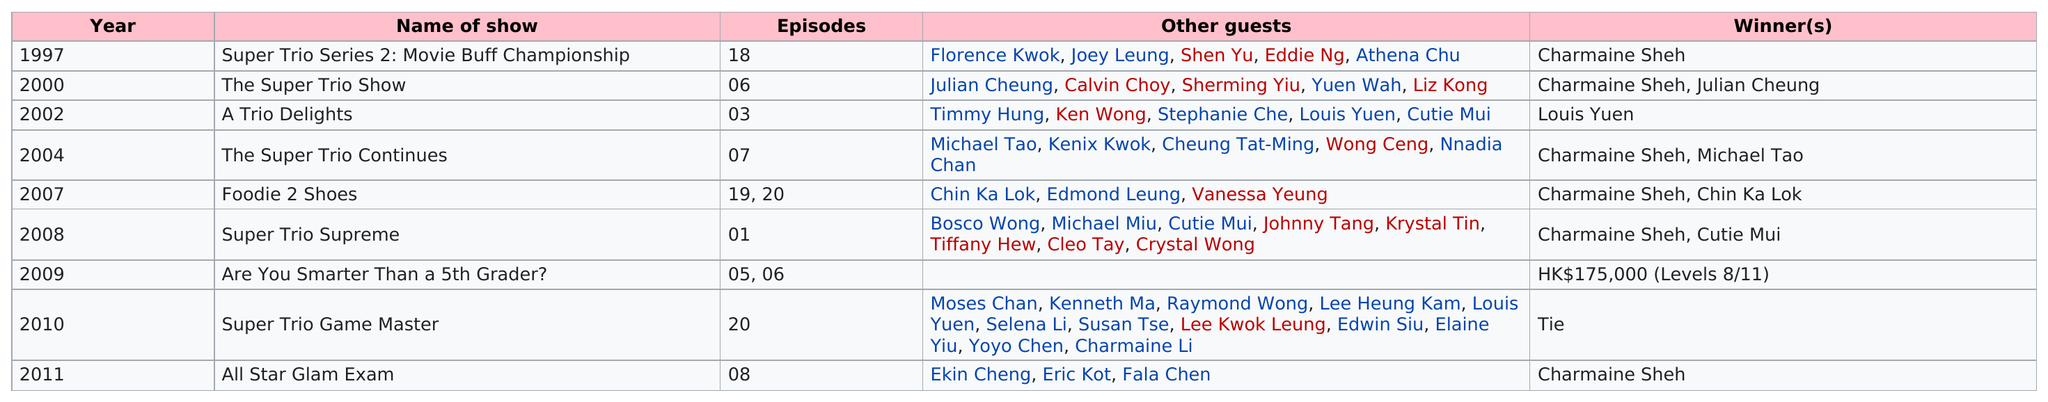Identify some key points in this picture. Charmaine Sheh has won on a variety show a total of 6 times. There are a total of 24 episodes that were created before the year 2002. There were five other guests in the 2002 show "A Trio Delights. In 2010, a tie occurred, making it the only year in which this event took place. Chermaine Sheh first appeared on a variety show 17 years ago. 